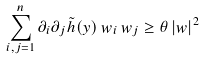<formula> <loc_0><loc_0><loc_500><loc_500>\sum _ { i , j = 1 } ^ { n } \partial _ { i } \partial _ { j } \tilde { h } ( y ) \, w _ { i } \, w _ { j } \geq \theta \, | w | ^ { 2 }</formula> 